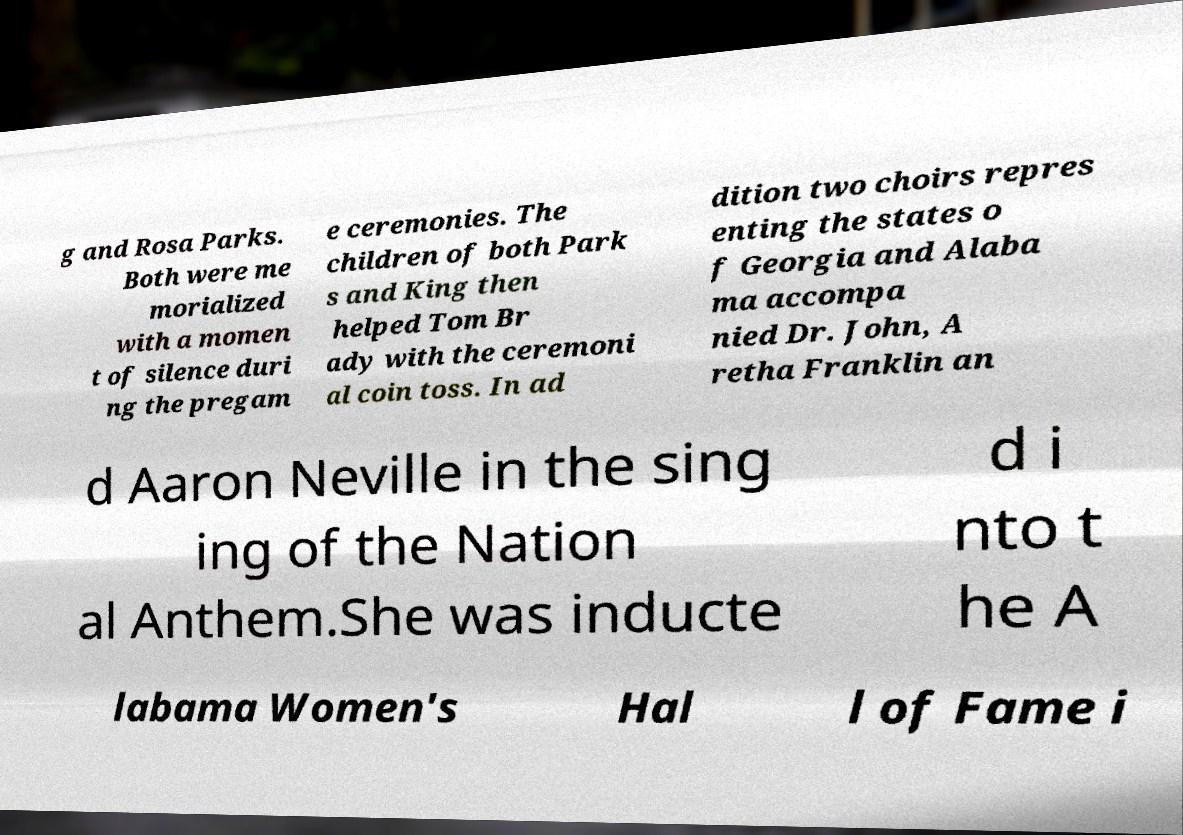Could you extract and type out the text from this image? g and Rosa Parks. Both were me morialized with a momen t of silence duri ng the pregam e ceremonies. The children of both Park s and King then helped Tom Br ady with the ceremoni al coin toss. In ad dition two choirs repres enting the states o f Georgia and Alaba ma accompa nied Dr. John, A retha Franklin an d Aaron Neville in the sing ing of the Nation al Anthem.She was inducte d i nto t he A labama Women's Hal l of Fame i 